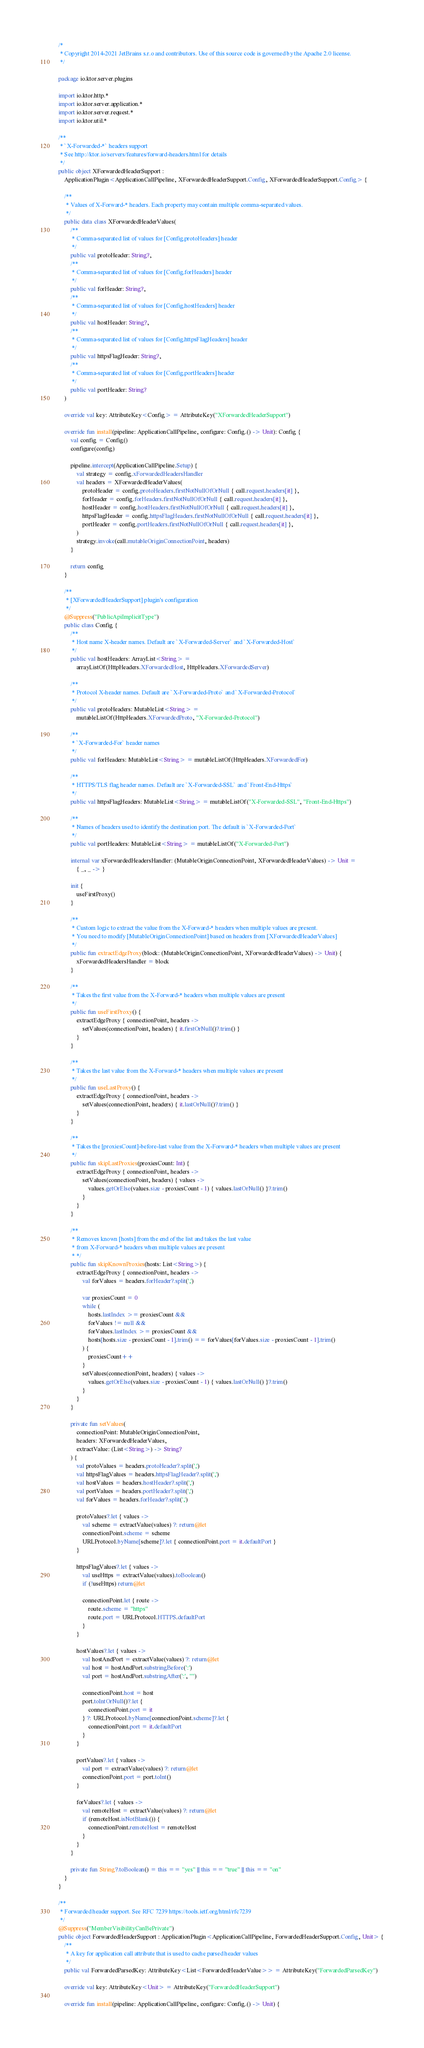Convert code to text. <code><loc_0><loc_0><loc_500><loc_500><_Kotlin_>/*
 * Copyright 2014-2021 JetBrains s.r.o and contributors. Use of this source code is governed by the Apache 2.0 license.
 */

package io.ktor.server.plugins

import io.ktor.http.*
import io.ktor.server.application.*
import io.ktor.server.request.*
import io.ktor.util.*

/**
 * `X-Forwarded-*` headers support
 * See http://ktor.io/servers/features/forward-headers.html for details
 */
public object XForwardedHeaderSupport :
    ApplicationPlugin<ApplicationCallPipeline, XForwardedHeaderSupport.Config, XForwardedHeaderSupport.Config> {

    /**
     * Values of X-Forward-* headers. Each property may contain multiple comma-separated values.
     */
    public data class XForwardedHeaderValues(
        /**
         * Comma-separated list of values for [Config.protoHeaders] header
         */
        public val protoHeader: String?,
        /**
         * Comma-separated list of values for [Config.forHeaders] header
         */
        public val forHeader: String?,
        /**
         * Comma-separated list of values for [Config.hostHeaders] header
         */
        public val hostHeader: String?,
        /**
         * Comma-separated list of values for [Config.httpsFlagHeaders] header
         */
        public val httpsFlagHeader: String?,
        /**
         * Comma-separated list of values for [Config.portHeaders] header
         */
        public val portHeader: String?
    )

    override val key: AttributeKey<Config> = AttributeKey("XForwardedHeaderSupport")

    override fun install(pipeline: ApplicationCallPipeline, configure: Config.() -> Unit): Config {
        val config = Config()
        configure(config)

        pipeline.intercept(ApplicationCallPipeline.Setup) {
            val strategy = config.xForwardedHeadersHandler
            val headers = XForwardedHeaderValues(
                protoHeader = config.protoHeaders.firstNotNullOfOrNull { call.request.headers[it] },
                forHeader = config.forHeaders.firstNotNullOfOrNull { call.request.headers[it] },
                hostHeader = config.hostHeaders.firstNotNullOfOrNull { call.request.headers[it] },
                httpsFlagHeader = config.httpsFlagHeaders.firstNotNullOfOrNull { call.request.headers[it] },
                portHeader = config.portHeaders.firstNotNullOfOrNull { call.request.headers[it] },
            )
            strategy.invoke(call.mutableOriginConnectionPoint, headers)
        }

        return config
    }

    /**
     * [XForwardedHeaderSupport] plugin's configuration
     */
    @Suppress("PublicApiImplicitType")
    public class Config {
        /**
         * Host name X-header names. Default are `X-Forwarded-Server` and `X-Forwarded-Host`
         */
        public val hostHeaders: ArrayList<String> =
            arrayListOf(HttpHeaders.XForwardedHost, HttpHeaders.XForwardedServer)

        /**
         * Protocol X-header names. Default are `X-Forwarded-Proto` and `X-Forwarded-Protocol`
         */
        public val protoHeaders: MutableList<String> =
            mutableListOf(HttpHeaders.XForwardedProto, "X-Forwarded-Protocol")

        /**
         * `X-Forwarded-For` header names
         */
        public val forHeaders: MutableList<String> = mutableListOf(HttpHeaders.XForwardedFor)

        /**
         * HTTPS/TLS flag header names. Default are `X-Forwarded-SSL` and `Front-End-Https`
         */
        public val httpsFlagHeaders: MutableList<String> = mutableListOf("X-Forwarded-SSL", "Front-End-Https")

        /**
         * Names of headers used to identify the destination port. The default is `X-Forwarded-Port`
         */
        public val portHeaders: MutableList<String> = mutableListOf("X-Forwarded-Port")

        internal var xForwardedHeadersHandler: (MutableOriginConnectionPoint, XForwardedHeaderValues) -> Unit =
            { _, _ -> }

        init {
            useFirstProxy()
        }

        /**
         * Custom logic to extract the value from the X-Forward-* headers when multiple values are present.
         * You need to modify [MutableOriginConnectionPoint] based on headers from [XForwardedHeaderValues]
         */
        public fun extractEdgeProxy(block: (MutableOriginConnectionPoint, XForwardedHeaderValues) -> Unit) {
            xForwardedHeadersHandler = block
        }

        /**
         * Takes the first value from the X-Forward-* headers when multiple values are present
         */
        public fun useFirstProxy() {
            extractEdgeProxy { connectionPoint, headers ->
                setValues(connectionPoint, headers) { it.firstOrNull()?.trim() }
            }
        }

        /**
         * Takes the last value from the X-Forward-* headers when multiple values are present
         */
        public fun useLastProxy() {
            extractEdgeProxy { connectionPoint, headers ->
                setValues(connectionPoint, headers) { it.lastOrNull()?.trim() }
            }
        }

        /**
         * Takes the [proxiesCount]-before-last value from the X-Forward-* headers when multiple values are present
         */
        public fun skipLastProxies(proxiesCount: Int) {
            extractEdgeProxy { connectionPoint, headers ->
                setValues(connectionPoint, headers) { values ->
                    values.getOrElse(values.size - proxiesCount - 1) { values.lastOrNull() }?.trim()
                }
            }
        }

        /**
         * Removes known [hosts] from the end of the list and takes the last value
         * from X-Forward-* headers when multiple values are present
         * */
        public fun skipKnownProxies(hosts: List<String>) {
            extractEdgeProxy { connectionPoint, headers ->
                val forValues = headers.forHeader?.split(',')

                var proxiesCount = 0
                while (
                    hosts.lastIndex >= proxiesCount &&
                    forValues != null &&
                    forValues.lastIndex >= proxiesCount &&
                    hosts[hosts.size - proxiesCount - 1].trim() == forValues[forValues.size - proxiesCount - 1].trim()
                ) {
                    proxiesCount++
                }
                setValues(connectionPoint, headers) { values ->
                    values.getOrElse(values.size - proxiesCount - 1) { values.lastOrNull() }?.trim()
                }
            }
        }

        private fun setValues(
            connectionPoint: MutableOriginConnectionPoint,
            headers: XForwardedHeaderValues,
            extractValue: (List<String>) -> String?
        ) {
            val protoValues = headers.protoHeader?.split(',')
            val httpsFlagValues = headers.httpsFlagHeader?.split(',')
            val hostValues = headers.hostHeader?.split(',')
            val portValues = headers.portHeader?.split(',')
            val forValues = headers.forHeader?.split(',')

            protoValues?.let { values ->
                val scheme = extractValue(values) ?: return@let
                connectionPoint.scheme = scheme
                URLProtocol.byName[scheme]?.let { connectionPoint.port = it.defaultPort }
            }

            httpsFlagValues?.let { values ->
                val useHttps = extractValue(values).toBoolean()
                if (!useHttps) return@let

                connectionPoint.let { route ->
                    route.scheme = "https"
                    route.port = URLProtocol.HTTPS.defaultPort
                }
            }

            hostValues?.let { values ->
                val hostAndPort = extractValue(values) ?: return@let
                val host = hostAndPort.substringBefore(':')
                val port = hostAndPort.substringAfter(':', "")

                connectionPoint.host = host
                port.toIntOrNull()?.let {
                    connectionPoint.port = it
                } ?: URLProtocol.byName[connectionPoint.scheme]?.let {
                    connectionPoint.port = it.defaultPort
                }
            }

            portValues?.let { values ->
                val port = extractValue(values) ?: return@let
                connectionPoint.port = port.toInt()
            }

            forValues?.let { values ->
                val remoteHost = extractValue(values) ?: return@let
                if (remoteHost.isNotBlank()) {
                    connectionPoint.remoteHost = remoteHost
                }
            }
        }

        private fun String?.toBoolean() = this == "yes" || this == "true" || this == "on"
    }
}

/**
 * Forwarded header support. See RFC 7239 https://tools.ietf.org/html/rfc7239
 */
@Suppress("MemberVisibilityCanBePrivate")
public object ForwardedHeaderSupport : ApplicationPlugin<ApplicationCallPipeline, ForwardedHeaderSupport.Config, Unit> {
    /**
     * A key for application call attribute that is used to cache parsed header values
     */
    public val ForwardedParsedKey: AttributeKey<List<ForwardedHeaderValue>> = AttributeKey("ForwardedParsedKey")

    override val key: AttributeKey<Unit> = AttributeKey("ForwardedHeaderSupport")

    override fun install(pipeline: ApplicationCallPipeline, configure: Config.() -> Unit) {</code> 